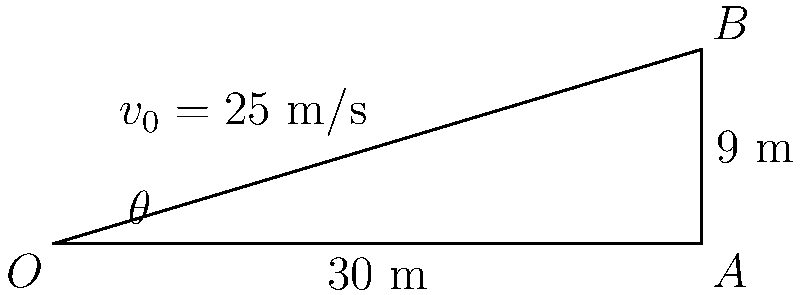During a crucial match at Huish Park, you're lining up for a free kick 30 meters from the goal. The crossbar is 9 meters high. If you strike the ball with an initial velocity of 25 m/s, at what angle $\theta$ should you kick the ball for it to just clear the crossbar? (Ignore air resistance and assume the ball travels in a parabolic path.) To solve this problem, we'll use the equations of projectile motion. Here's a step-by-step approach:

1) The range equation for a projectile is:
   $$R = \frac{v_0^2 \sin(2\theta)}{g}$$
   where $R$ is the range, $v_0$ is the initial velocity, $\theta$ is the launch angle, and $g$ is the acceleration due to gravity (9.8 m/s²).

2) The maximum height equation is:
   $$h = \frac{v_0^2 \sin^2(\theta)}{2g}$$

3) In our case, $R = 30$ m, $h = 9$ m, and $v_0 = 25$ m/s.

4) Dividing the height equation by the range equation:
   $$\frac{h}{R} = \frac{\sin^2(\theta)}{2\sin(2\theta)} = \frac{\tan(\theta)}{4}$$

5) Substituting our known values:
   $$\frac{9}{30} = \frac{\tan(\theta)}{4}$$

6) Solving for $\theta$:
   $$\tan(\theta) = 4 \cdot \frac{9}{30} = 1.2$$
   $$\theta = \arctan(1.2) \approx 50.2^\circ$$

7) We can verify this using the range equation:
   $$30 = \frac{25^2 \sin(2 \cdot 50.2^\circ)}{9.8}$$

This angle will make the ball just clear the crossbar at the highest point of its trajectory.
Answer: $50.2^\circ$ 